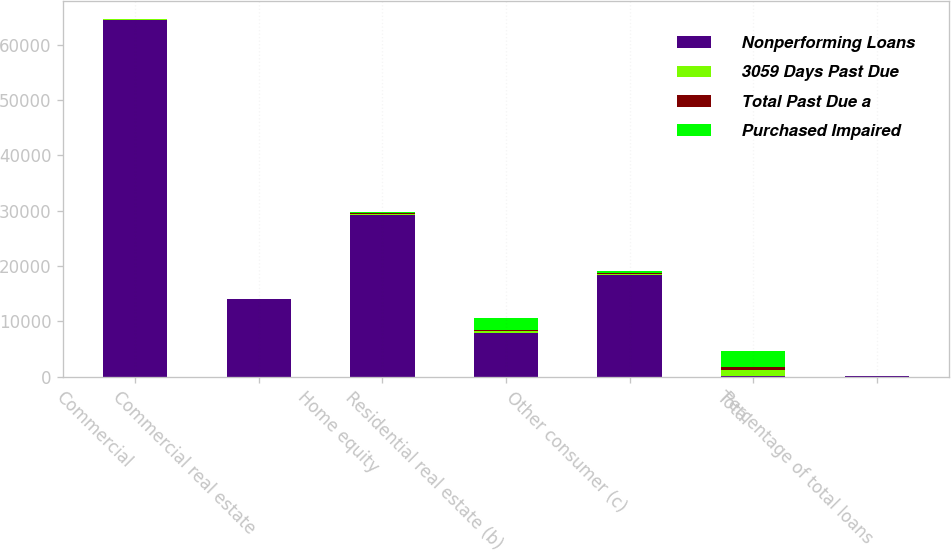Convert chart to OTSL. <chart><loc_0><loc_0><loc_500><loc_500><stacked_bar_chart><ecel><fcel>Commercial<fcel>Commercial real estate<fcel>Home equity<fcel>Residential real estate (b)<fcel>Other consumer (c)<fcel>Total<fcel>Percentage of total loans<nl><fcel>Nonperforming Loans<fcel>64437<fcel>14010<fcel>29288<fcel>7935<fcel>18355<fcel>176<fcel>90.72<nl><fcel>3059 Days Past Due<fcel>122<fcel>96<fcel>173<fcel>302<fcel>265<fcel>1018<fcel>0.64<nl><fcel>Total Past Due a<fcel>47<fcel>35<fcel>114<fcel>176<fcel>145<fcel>547<fcel>0.34<nl><fcel>Purchased Impaired<fcel>49<fcel>6<fcel>221<fcel>2281<fcel>368<fcel>2973<fcel>1.87<nl></chart> 